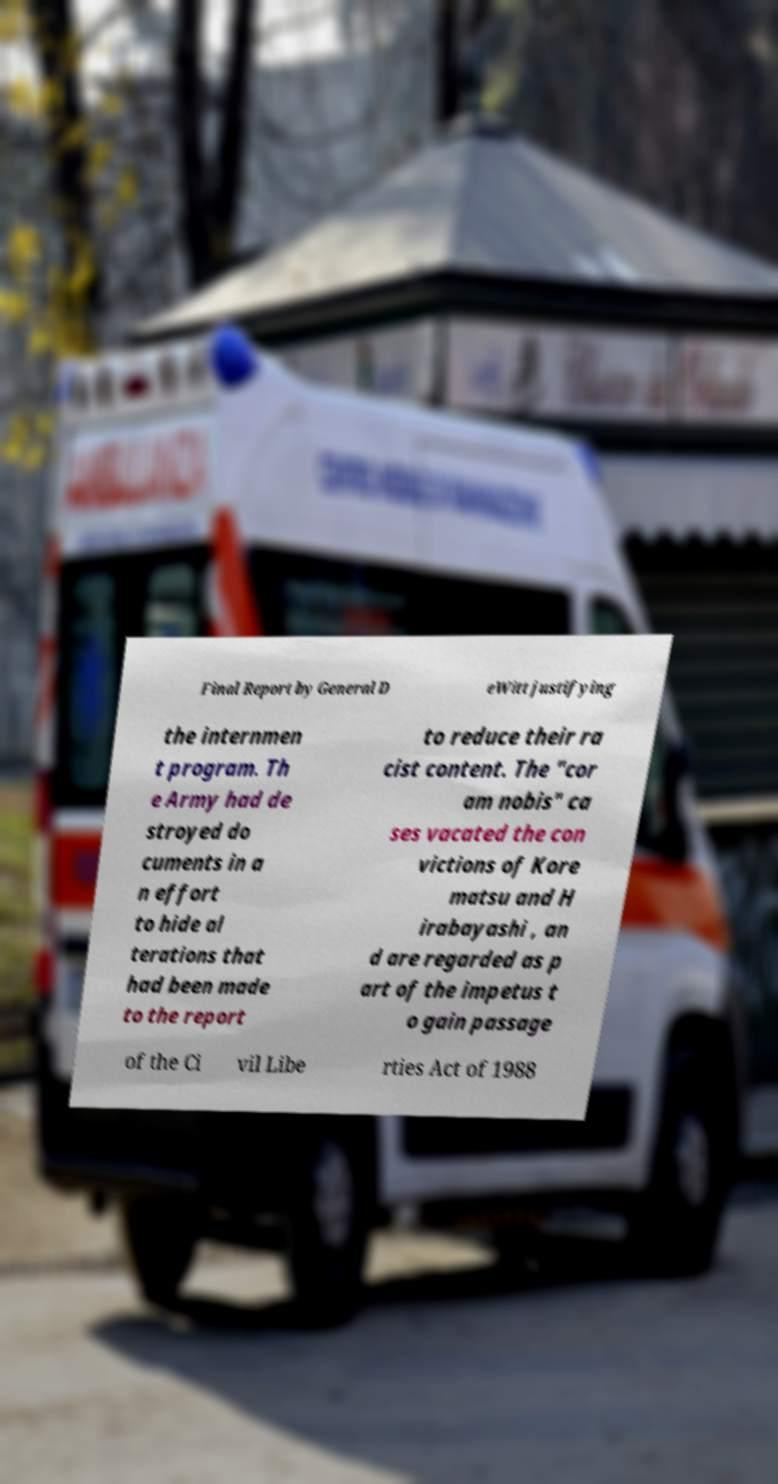What messages or text are displayed in this image? I need them in a readable, typed format. Final Report by General D eWitt justifying the internmen t program. Th e Army had de stroyed do cuments in a n effort to hide al terations that had been made to the report to reduce their ra cist content. The "cor am nobis" ca ses vacated the con victions of Kore matsu and H irabayashi , an d are regarded as p art of the impetus t o gain passage of the Ci vil Libe rties Act of 1988 